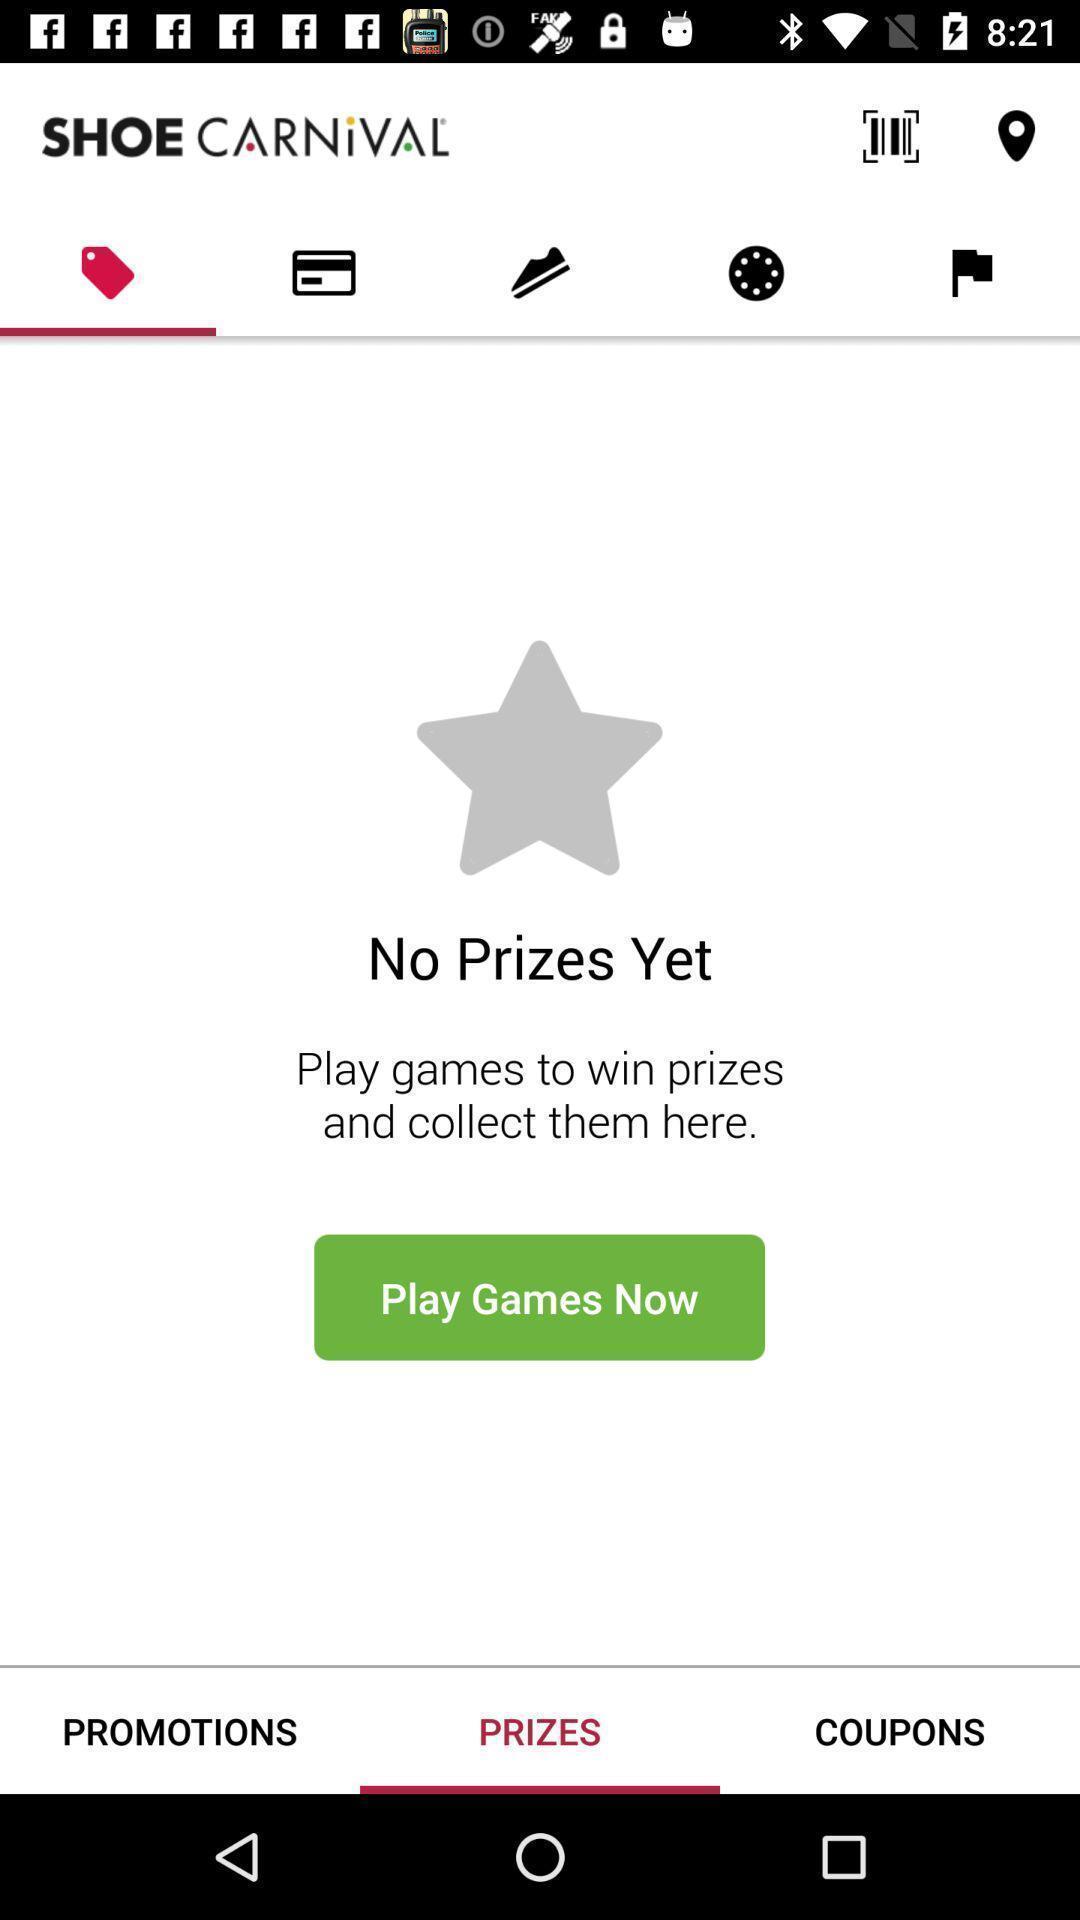What details can you identify in this image? Window displaying a footwear app. 